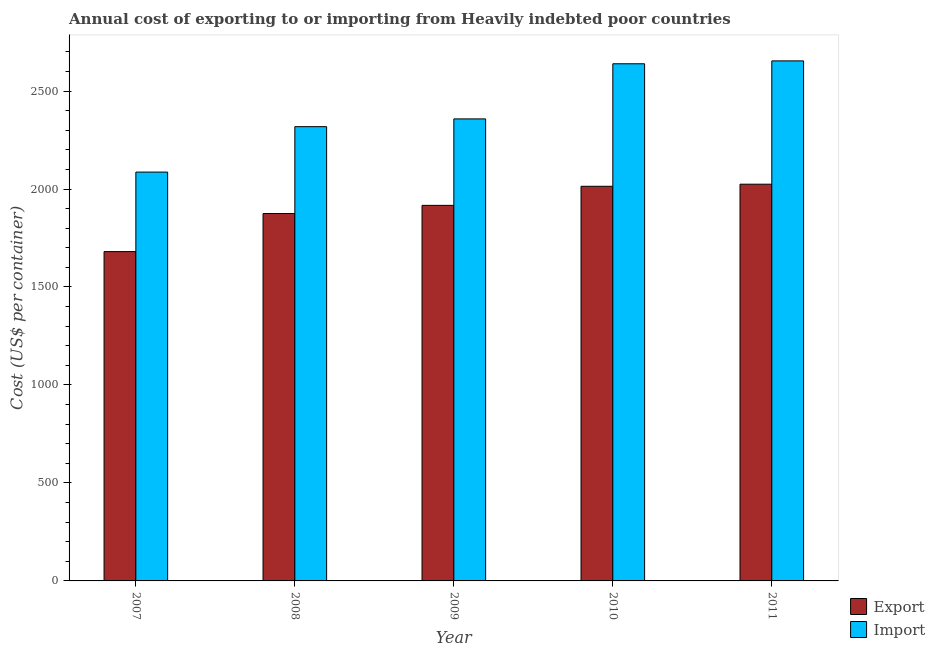Are the number of bars per tick equal to the number of legend labels?
Your answer should be very brief. Yes. Are the number of bars on each tick of the X-axis equal?
Give a very brief answer. Yes. How many bars are there on the 3rd tick from the left?
Make the answer very short. 2. What is the label of the 4th group of bars from the left?
Make the answer very short. 2010. What is the export cost in 2010?
Offer a terse response. 2013.84. Across all years, what is the maximum import cost?
Keep it short and to the point. 2653.87. Across all years, what is the minimum import cost?
Offer a very short reply. 2086.37. In which year was the import cost maximum?
Provide a succinct answer. 2011. In which year was the export cost minimum?
Offer a very short reply. 2007. What is the total import cost in the graph?
Offer a terse response. 1.21e+04. What is the difference between the export cost in 2007 and that in 2009?
Your answer should be compact. -235.92. What is the difference between the import cost in 2008 and the export cost in 2009?
Provide a succinct answer. -39.66. What is the average export cost per year?
Your answer should be very brief. 1902.05. In how many years, is the import cost greater than 1000 US$?
Keep it short and to the point. 5. What is the ratio of the export cost in 2007 to that in 2009?
Your answer should be very brief. 0.88. What is the difference between the highest and the second highest export cost?
Give a very brief answer. 10.71. What is the difference between the highest and the lowest export cost?
Offer a terse response. 344. Is the sum of the export cost in 2007 and 2010 greater than the maximum import cost across all years?
Provide a succinct answer. Yes. What does the 2nd bar from the left in 2011 represents?
Offer a terse response. Import. What does the 2nd bar from the right in 2007 represents?
Ensure brevity in your answer.  Export. How many bars are there?
Your answer should be very brief. 10. Are all the bars in the graph horizontal?
Keep it short and to the point. No. How many years are there in the graph?
Give a very brief answer. 5. What is the difference between two consecutive major ticks on the Y-axis?
Your response must be concise. 500. Are the values on the major ticks of Y-axis written in scientific E-notation?
Ensure brevity in your answer.  No. Does the graph contain any zero values?
Provide a succinct answer. No. Does the graph contain grids?
Ensure brevity in your answer.  No. How many legend labels are there?
Keep it short and to the point. 2. What is the title of the graph?
Your answer should be very brief. Annual cost of exporting to or importing from Heavily indebted poor countries. What is the label or title of the X-axis?
Your answer should be very brief. Year. What is the label or title of the Y-axis?
Keep it short and to the point. Cost (US$ per container). What is the Cost (US$ per container) of Export in 2007?
Ensure brevity in your answer.  1680.55. What is the Cost (US$ per container) in Import in 2007?
Keep it short and to the point. 2086.37. What is the Cost (US$ per container) of Export in 2008?
Provide a succinct answer. 1874.84. What is the Cost (US$ per container) in Import in 2008?
Your answer should be compact. 2318.13. What is the Cost (US$ per container) of Export in 2009?
Keep it short and to the point. 1916.47. What is the Cost (US$ per container) in Import in 2009?
Provide a succinct answer. 2357.79. What is the Cost (US$ per container) of Export in 2010?
Make the answer very short. 2013.84. What is the Cost (US$ per container) in Import in 2010?
Make the answer very short. 2639.05. What is the Cost (US$ per container) of Export in 2011?
Provide a short and direct response. 2024.55. What is the Cost (US$ per container) in Import in 2011?
Make the answer very short. 2653.87. Across all years, what is the maximum Cost (US$ per container) of Export?
Ensure brevity in your answer.  2024.55. Across all years, what is the maximum Cost (US$ per container) of Import?
Provide a short and direct response. 2653.87. Across all years, what is the minimum Cost (US$ per container) of Export?
Ensure brevity in your answer.  1680.55. Across all years, what is the minimum Cost (US$ per container) of Import?
Provide a short and direct response. 2086.37. What is the total Cost (US$ per container) of Export in the graph?
Give a very brief answer. 9510.26. What is the total Cost (US$ per container) in Import in the graph?
Offer a very short reply. 1.21e+04. What is the difference between the Cost (US$ per container) of Export in 2007 and that in 2008?
Provide a succinct answer. -194.29. What is the difference between the Cost (US$ per container) of Import in 2007 and that in 2008?
Ensure brevity in your answer.  -231.76. What is the difference between the Cost (US$ per container) of Export in 2007 and that in 2009?
Your answer should be very brief. -235.92. What is the difference between the Cost (US$ per container) of Import in 2007 and that in 2009?
Your answer should be very brief. -271.42. What is the difference between the Cost (US$ per container) in Export in 2007 and that in 2010?
Provide a short and direct response. -333.29. What is the difference between the Cost (US$ per container) of Import in 2007 and that in 2010?
Your answer should be very brief. -552.68. What is the difference between the Cost (US$ per container) in Export in 2007 and that in 2011?
Ensure brevity in your answer.  -344. What is the difference between the Cost (US$ per container) of Import in 2007 and that in 2011?
Offer a terse response. -567.5. What is the difference between the Cost (US$ per container) of Export in 2008 and that in 2009?
Give a very brief answer. -41.63. What is the difference between the Cost (US$ per container) of Import in 2008 and that in 2009?
Give a very brief answer. -39.66. What is the difference between the Cost (US$ per container) of Export in 2008 and that in 2010?
Ensure brevity in your answer.  -139. What is the difference between the Cost (US$ per container) of Import in 2008 and that in 2010?
Make the answer very short. -320.92. What is the difference between the Cost (US$ per container) of Export in 2008 and that in 2011?
Offer a terse response. -149.71. What is the difference between the Cost (US$ per container) of Import in 2008 and that in 2011?
Give a very brief answer. -335.74. What is the difference between the Cost (US$ per container) in Export in 2009 and that in 2010?
Your answer should be compact. -97.37. What is the difference between the Cost (US$ per container) of Import in 2009 and that in 2010?
Provide a succinct answer. -281.26. What is the difference between the Cost (US$ per container) in Export in 2009 and that in 2011?
Your answer should be compact. -108.08. What is the difference between the Cost (US$ per container) of Import in 2009 and that in 2011?
Your response must be concise. -296.08. What is the difference between the Cost (US$ per container) in Export in 2010 and that in 2011?
Your answer should be very brief. -10.71. What is the difference between the Cost (US$ per container) in Import in 2010 and that in 2011?
Offer a very short reply. -14.82. What is the difference between the Cost (US$ per container) of Export in 2007 and the Cost (US$ per container) of Import in 2008?
Provide a succinct answer. -637.58. What is the difference between the Cost (US$ per container) of Export in 2007 and the Cost (US$ per container) of Import in 2009?
Give a very brief answer. -677.24. What is the difference between the Cost (US$ per container) in Export in 2007 and the Cost (US$ per container) in Import in 2010?
Ensure brevity in your answer.  -958.5. What is the difference between the Cost (US$ per container) of Export in 2007 and the Cost (US$ per container) of Import in 2011?
Your response must be concise. -973.32. What is the difference between the Cost (US$ per container) of Export in 2008 and the Cost (US$ per container) of Import in 2009?
Provide a succinct answer. -482.95. What is the difference between the Cost (US$ per container) in Export in 2008 and the Cost (US$ per container) in Import in 2010?
Your response must be concise. -764.21. What is the difference between the Cost (US$ per container) in Export in 2008 and the Cost (US$ per container) in Import in 2011?
Offer a very short reply. -779.03. What is the difference between the Cost (US$ per container) of Export in 2009 and the Cost (US$ per container) of Import in 2010?
Your answer should be very brief. -722.58. What is the difference between the Cost (US$ per container) of Export in 2009 and the Cost (US$ per container) of Import in 2011?
Offer a terse response. -737.39. What is the difference between the Cost (US$ per container) in Export in 2010 and the Cost (US$ per container) in Import in 2011?
Give a very brief answer. -640.03. What is the average Cost (US$ per container) of Export per year?
Provide a succinct answer. 1902.05. What is the average Cost (US$ per container) in Import per year?
Offer a very short reply. 2411.04. In the year 2007, what is the difference between the Cost (US$ per container) of Export and Cost (US$ per container) of Import?
Ensure brevity in your answer.  -405.82. In the year 2008, what is the difference between the Cost (US$ per container) of Export and Cost (US$ per container) of Import?
Your response must be concise. -443.29. In the year 2009, what is the difference between the Cost (US$ per container) of Export and Cost (US$ per container) of Import?
Offer a very short reply. -441.32. In the year 2010, what is the difference between the Cost (US$ per container) of Export and Cost (US$ per container) of Import?
Your answer should be compact. -625.21. In the year 2011, what is the difference between the Cost (US$ per container) of Export and Cost (US$ per container) of Import?
Make the answer very short. -629.32. What is the ratio of the Cost (US$ per container) of Export in 2007 to that in 2008?
Your answer should be compact. 0.9. What is the ratio of the Cost (US$ per container) in Import in 2007 to that in 2008?
Your answer should be very brief. 0.9. What is the ratio of the Cost (US$ per container) of Export in 2007 to that in 2009?
Your answer should be very brief. 0.88. What is the ratio of the Cost (US$ per container) in Import in 2007 to that in 2009?
Offer a terse response. 0.88. What is the ratio of the Cost (US$ per container) in Export in 2007 to that in 2010?
Keep it short and to the point. 0.83. What is the ratio of the Cost (US$ per container) in Import in 2007 to that in 2010?
Keep it short and to the point. 0.79. What is the ratio of the Cost (US$ per container) of Export in 2007 to that in 2011?
Make the answer very short. 0.83. What is the ratio of the Cost (US$ per container) of Import in 2007 to that in 2011?
Keep it short and to the point. 0.79. What is the ratio of the Cost (US$ per container) in Export in 2008 to that in 2009?
Provide a short and direct response. 0.98. What is the ratio of the Cost (US$ per container) of Import in 2008 to that in 2009?
Offer a terse response. 0.98. What is the ratio of the Cost (US$ per container) of Export in 2008 to that in 2010?
Give a very brief answer. 0.93. What is the ratio of the Cost (US$ per container) in Import in 2008 to that in 2010?
Offer a very short reply. 0.88. What is the ratio of the Cost (US$ per container) of Export in 2008 to that in 2011?
Keep it short and to the point. 0.93. What is the ratio of the Cost (US$ per container) in Import in 2008 to that in 2011?
Keep it short and to the point. 0.87. What is the ratio of the Cost (US$ per container) in Export in 2009 to that in 2010?
Make the answer very short. 0.95. What is the ratio of the Cost (US$ per container) in Import in 2009 to that in 2010?
Offer a terse response. 0.89. What is the ratio of the Cost (US$ per container) of Export in 2009 to that in 2011?
Provide a short and direct response. 0.95. What is the ratio of the Cost (US$ per container) in Import in 2009 to that in 2011?
Your answer should be very brief. 0.89. What is the ratio of the Cost (US$ per container) of Export in 2010 to that in 2011?
Make the answer very short. 0.99. What is the difference between the highest and the second highest Cost (US$ per container) of Export?
Keep it short and to the point. 10.71. What is the difference between the highest and the second highest Cost (US$ per container) in Import?
Provide a short and direct response. 14.82. What is the difference between the highest and the lowest Cost (US$ per container) in Export?
Provide a short and direct response. 344. What is the difference between the highest and the lowest Cost (US$ per container) in Import?
Make the answer very short. 567.5. 